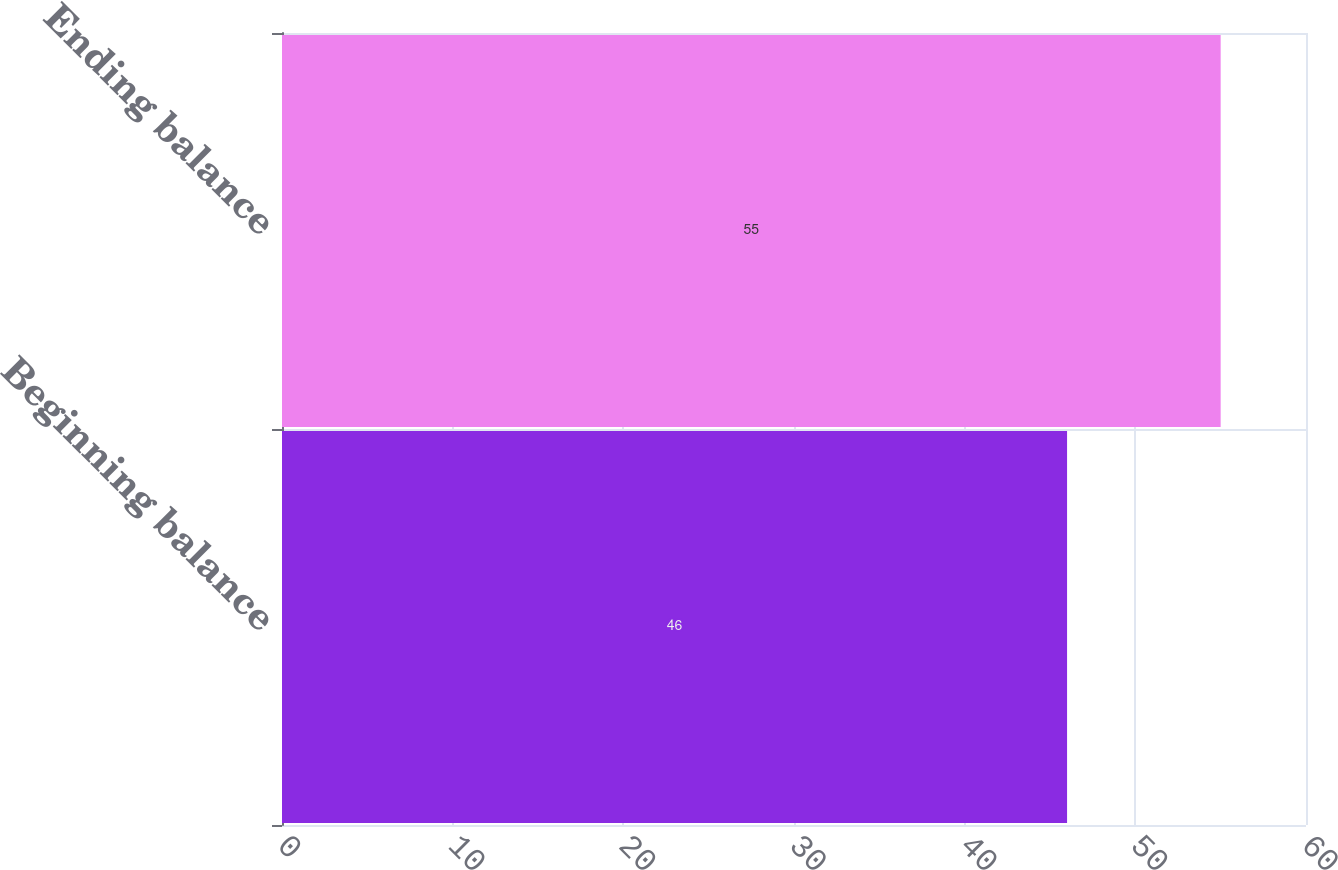Convert chart. <chart><loc_0><loc_0><loc_500><loc_500><bar_chart><fcel>Beginning balance<fcel>Ending balance<nl><fcel>46<fcel>55<nl></chart> 